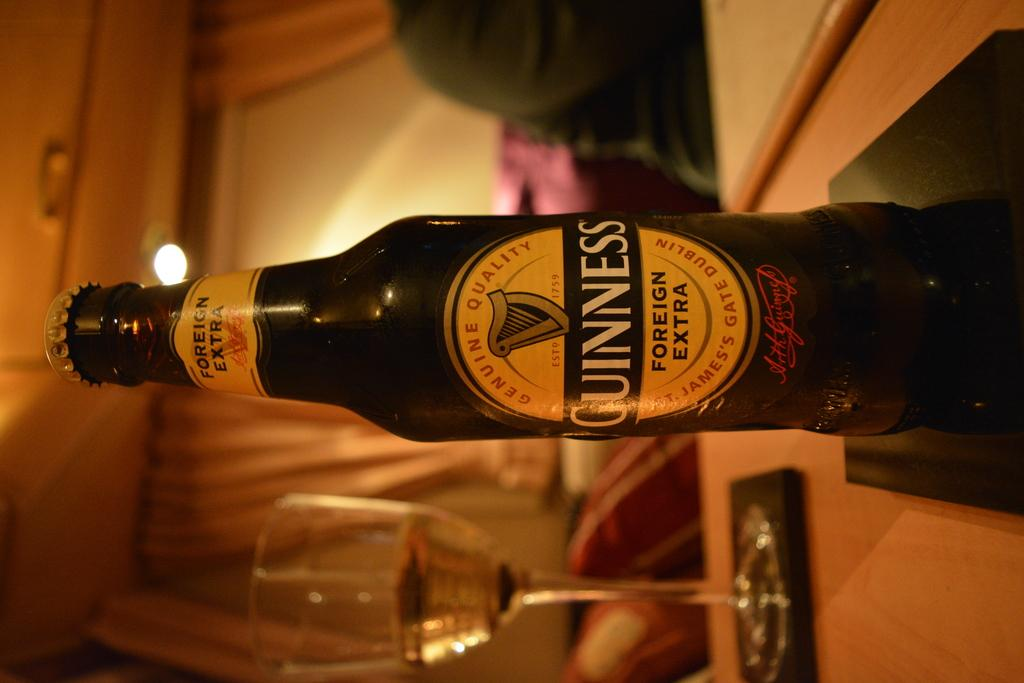<image>
Give a short and clear explanation of the subsequent image. A bottle of Guinness says foreign extra on the label. 